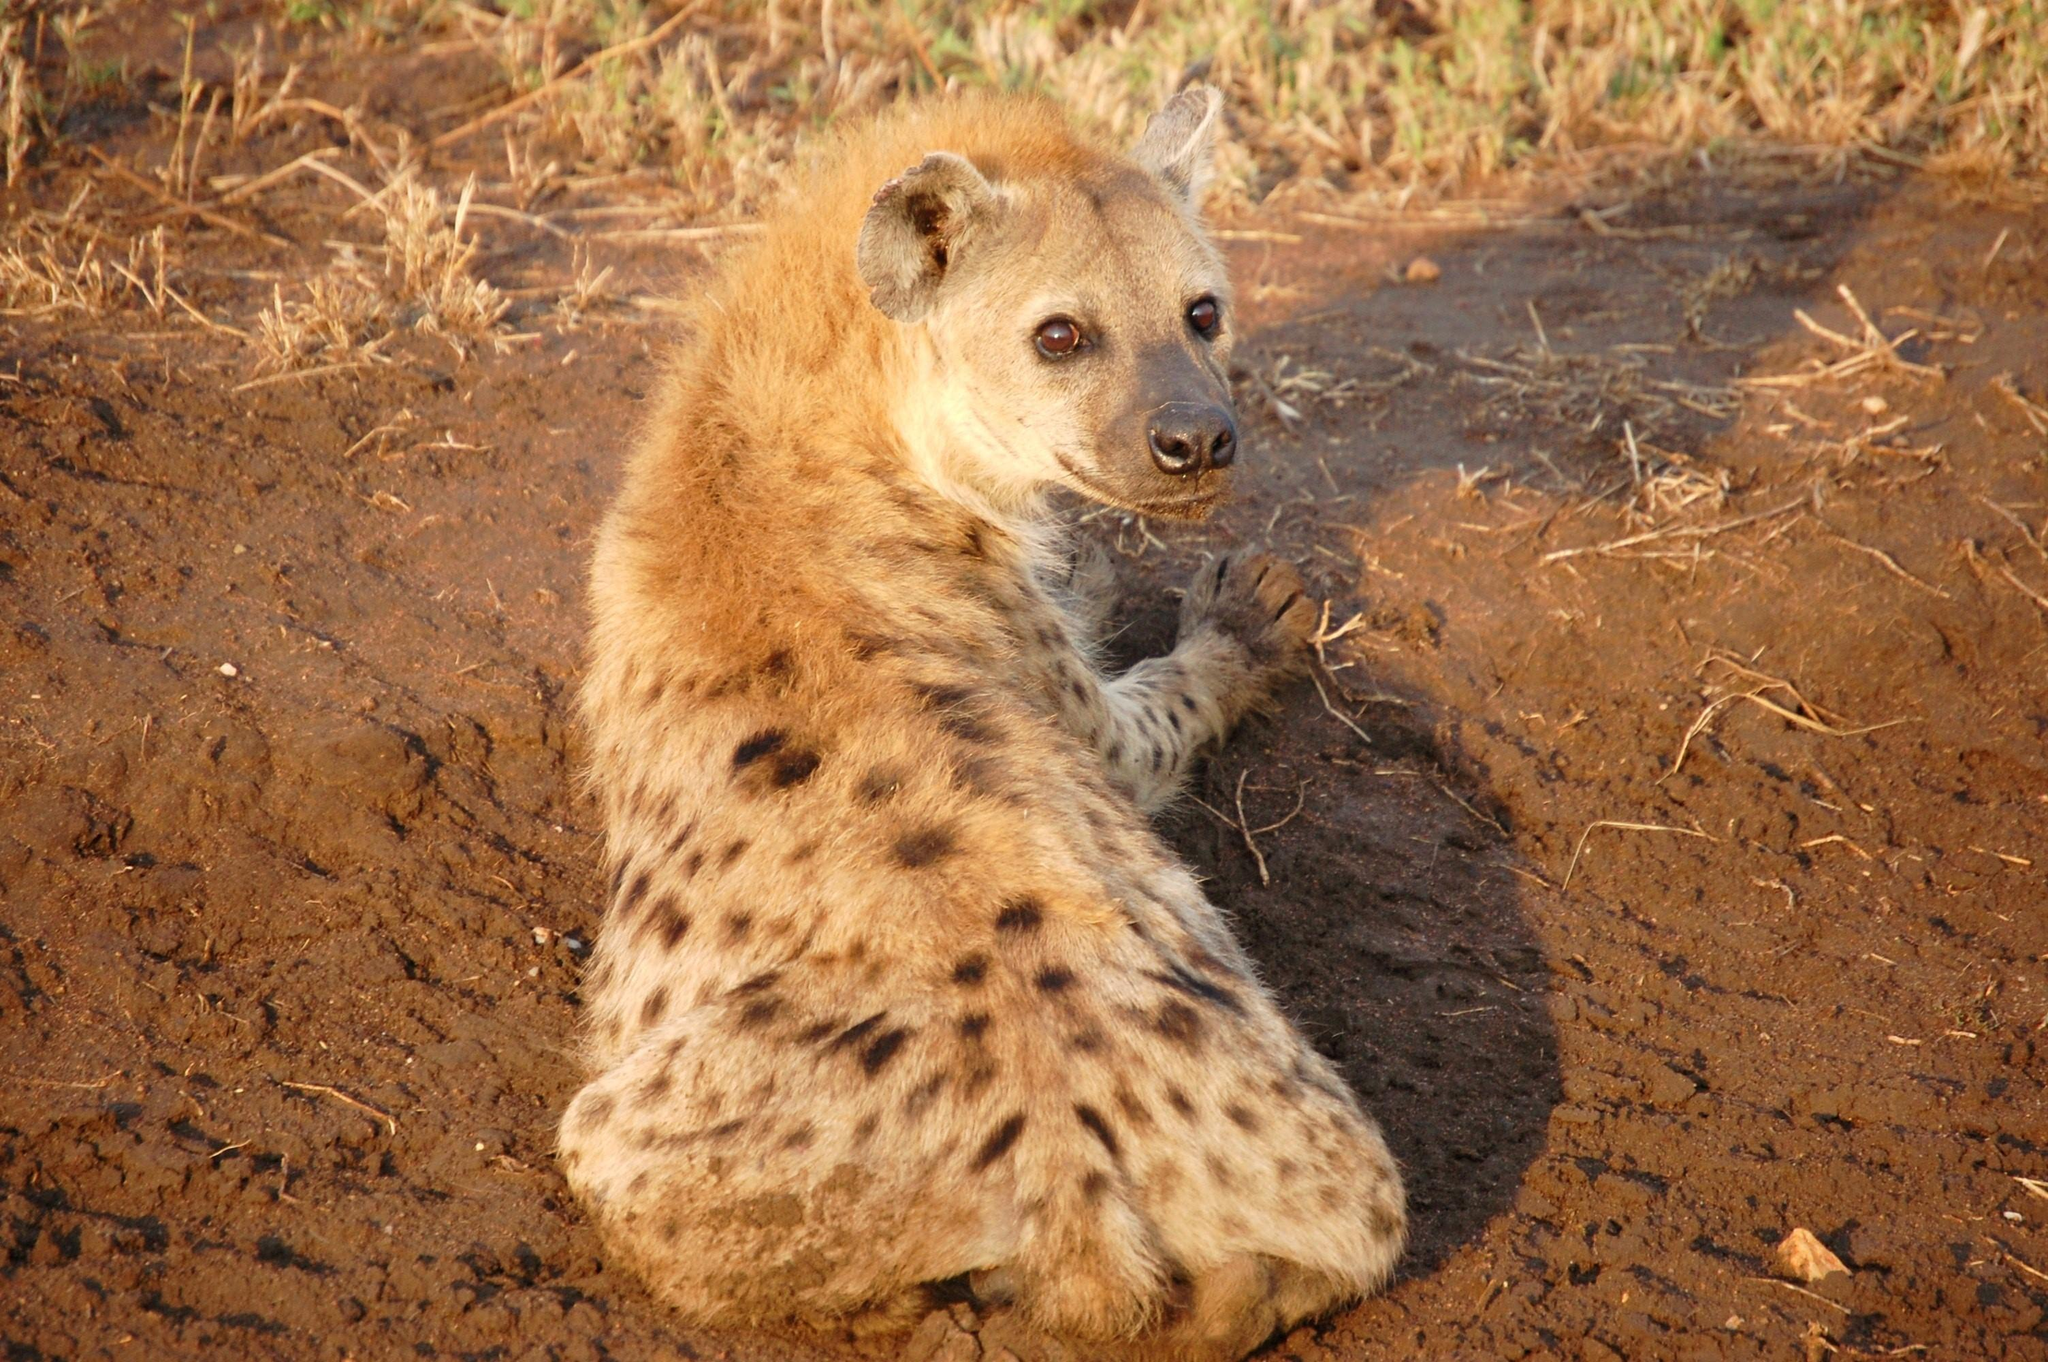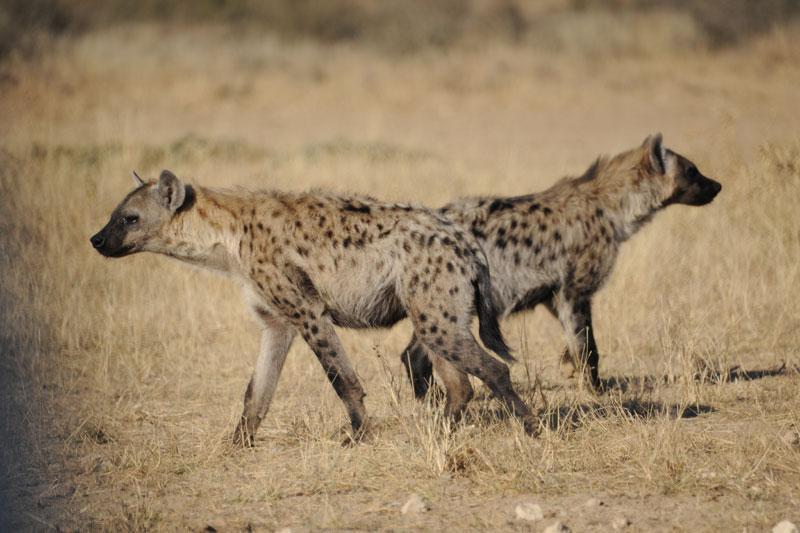The first image is the image on the left, the second image is the image on the right. Considering the images on both sides, is "There are a total of 3 hyena's." valid? Answer yes or no. Yes. The first image is the image on the left, the second image is the image on the right. Given the left and right images, does the statement "There are 2 animals facing opposite directions in the right image." hold true? Answer yes or no. Yes. 